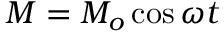<formula> <loc_0><loc_0><loc_500><loc_500>M = M _ { o } \cos \omega t</formula> 